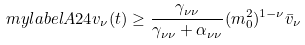<formula> <loc_0><loc_0><loc_500><loc_500>\ m y l a b e l { A 2 4 } v _ { \nu } ( t ) \geq \frac { \gamma _ { \nu \nu } } { \gamma _ { \nu \nu } + \alpha _ { \nu \nu } } ( m _ { 0 } ^ { 2 } ) ^ { 1 - \nu } \bar { v } _ { \nu }</formula> 